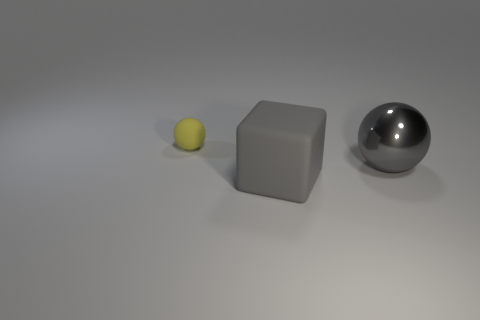Is there anything else that has the same shape as the yellow matte thing?
Make the answer very short. Yes. Is there a tiny yellow sphere?
Your answer should be compact. Yes. Do the thing on the left side of the big gray matte block and the big thing that is in front of the gray metallic object have the same material?
Your answer should be very brief. Yes. There is a object in front of the big object behind the matte thing in front of the yellow rubber ball; how big is it?
Provide a short and direct response. Large. How many other things are the same material as the tiny yellow object?
Provide a succinct answer. 1. Are there fewer large gray spheres than big yellow metallic cubes?
Your response must be concise. No. There is a rubber thing that is the same shape as the metallic thing; what is its size?
Your answer should be very brief. Small. Does the ball that is in front of the tiny yellow ball have the same material as the big gray cube?
Provide a short and direct response. No. Is the shape of the big gray metallic thing the same as the small thing?
Your response must be concise. Yes. What number of things are things that are in front of the yellow rubber thing or small objects?
Provide a succinct answer. 3. 